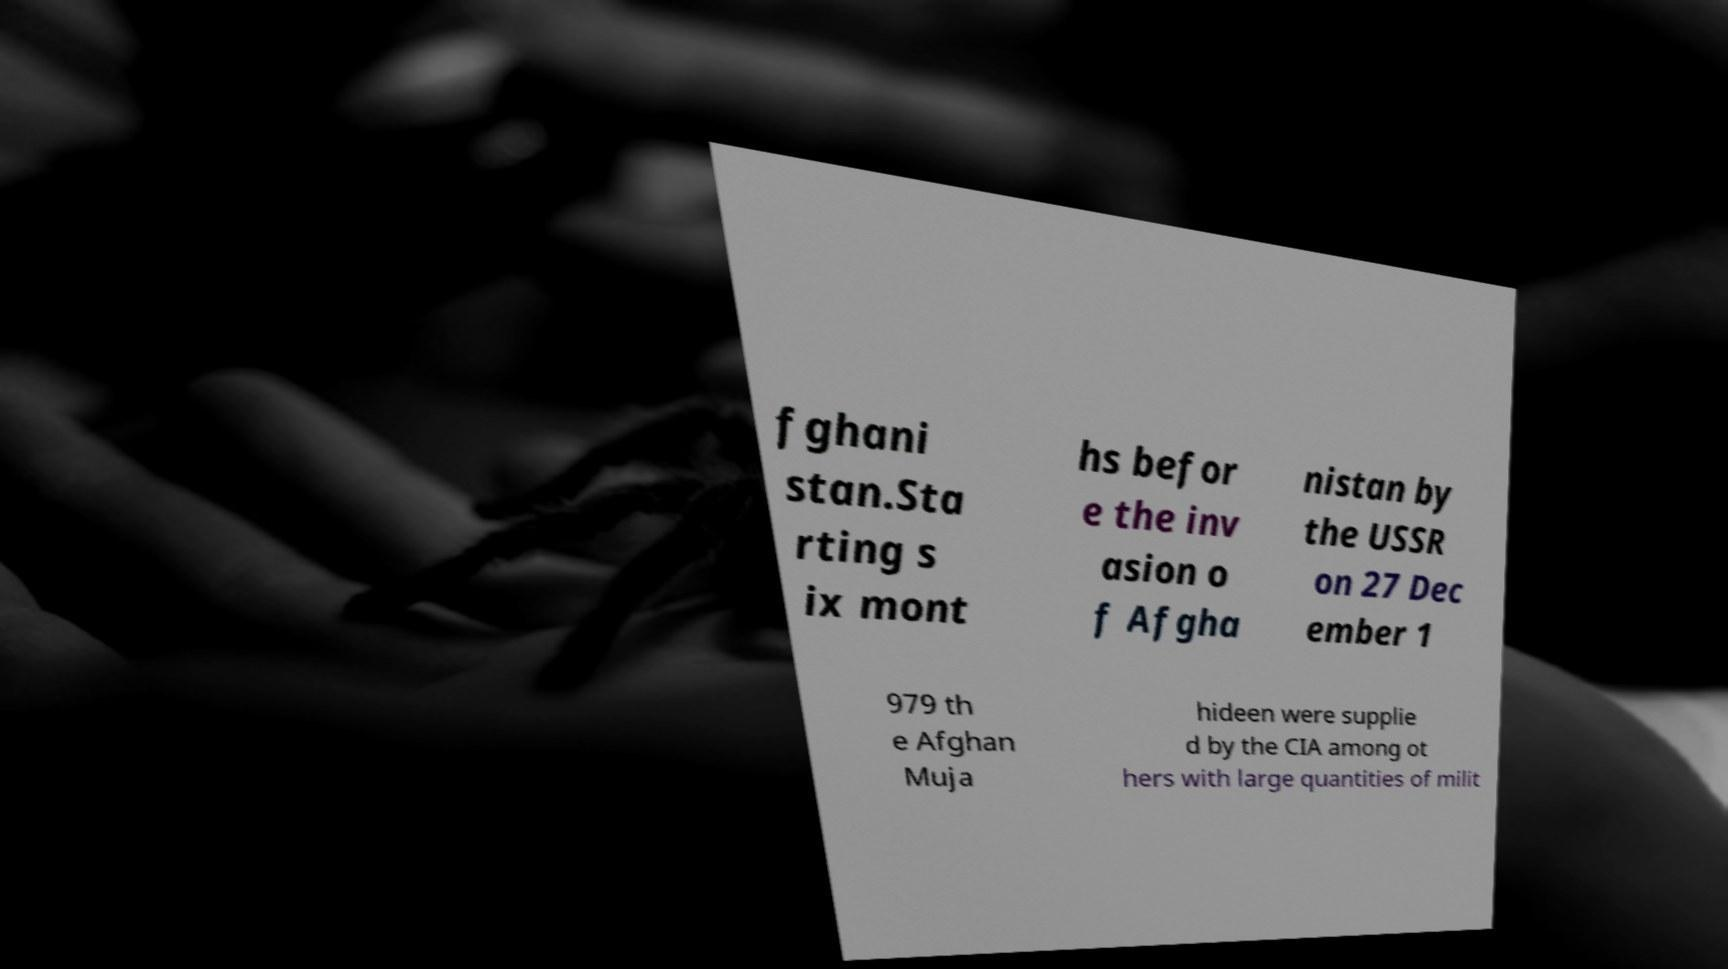Please read and relay the text visible in this image. What does it say? fghani stan.Sta rting s ix mont hs befor e the inv asion o f Afgha nistan by the USSR on 27 Dec ember 1 979 th e Afghan Muja hideen were supplie d by the CIA among ot hers with large quantities of milit 